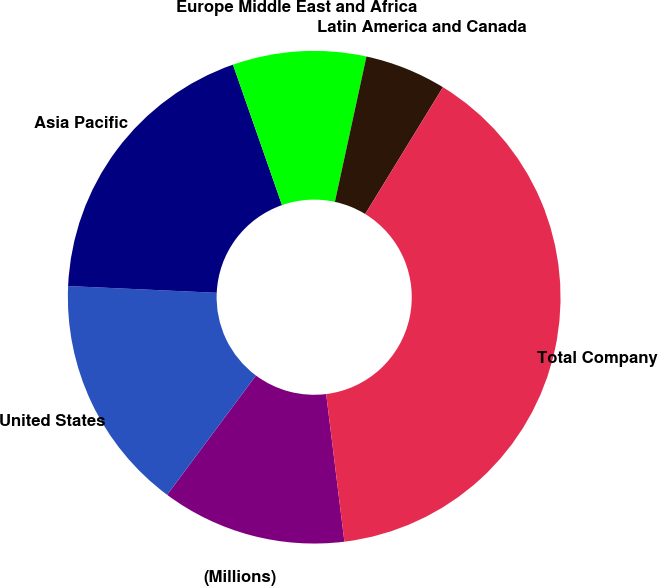Convert chart to OTSL. <chart><loc_0><loc_0><loc_500><loc_500><pie_chart><fcel>(Millions)<fcel>United States<fcel>Asia Pacific<fcel>Europe Middle East and Africa<fcel>Latin America and Canada<fcel>Total Company<nl><fcel>12.14%<fcel>15.54%<fcel>18.93%<fcel>8.75%<fcel>5.35%<fcel>39.29%<nl></chart> 